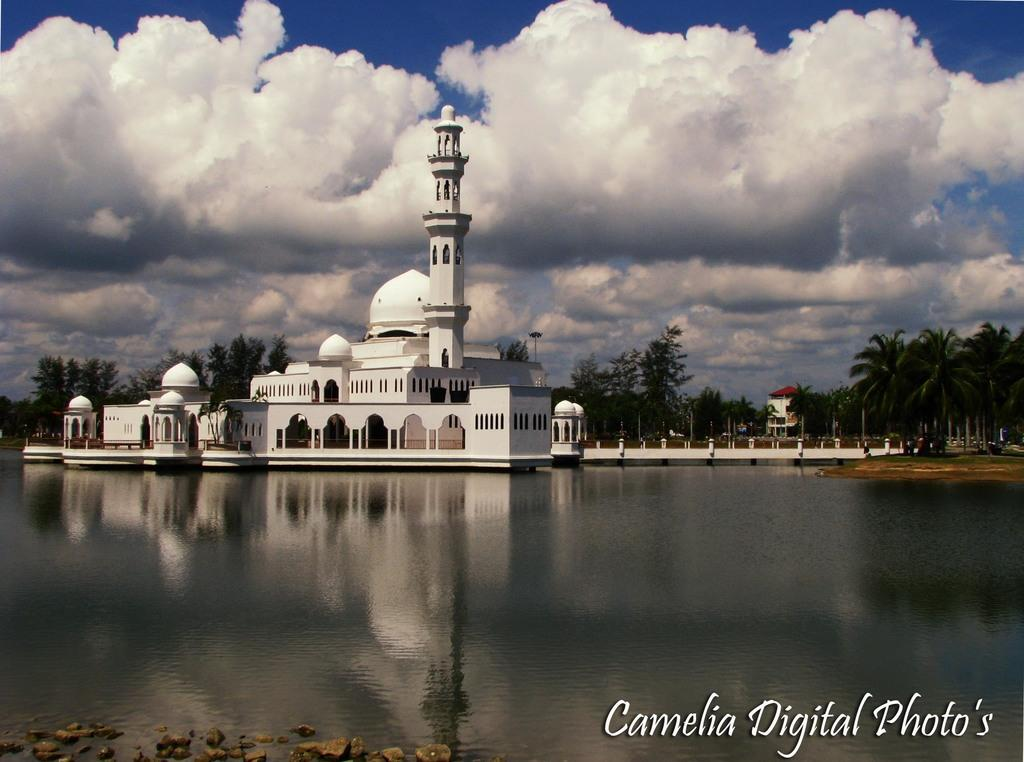What is located in front of the building in the image? There is a lake in front of the building in the image. What type of vegetation can be seen on the right side of the image? There are trees on the right side of the image. What is visible in the background of the image? The sky is visible in the background of the image. What type of chin can be seen on the trees in the image? There are no chins present in the image, as chins are a part of the human face and not a characteristic of trees. What is the weather like in the image? The provided facts do not mention the weather, so it cannot be determined from the image. 